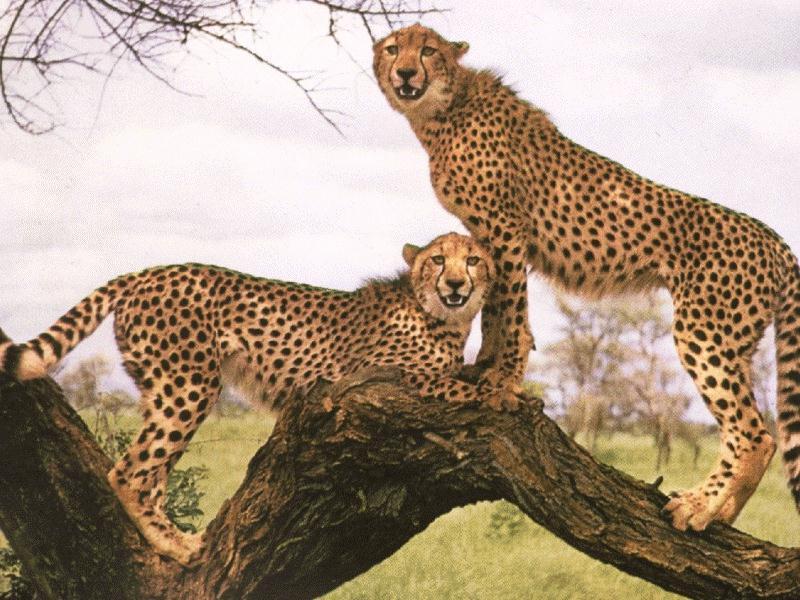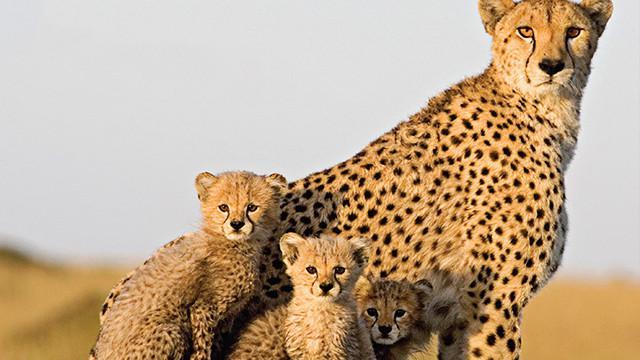The first image is the image on the left, the second image is the image on the right. Examine the images to the left and right. Is the description "An image shows one wild cat with its mouth and paw on the other wild cat." accurate? Answer yes or no. No. The first image is the image on the left, the second image is the image on the right. Analyze the images presented: Is the assertion "There are a total of 6 or more wild cats." valid? Answer yes or no. Yes. 